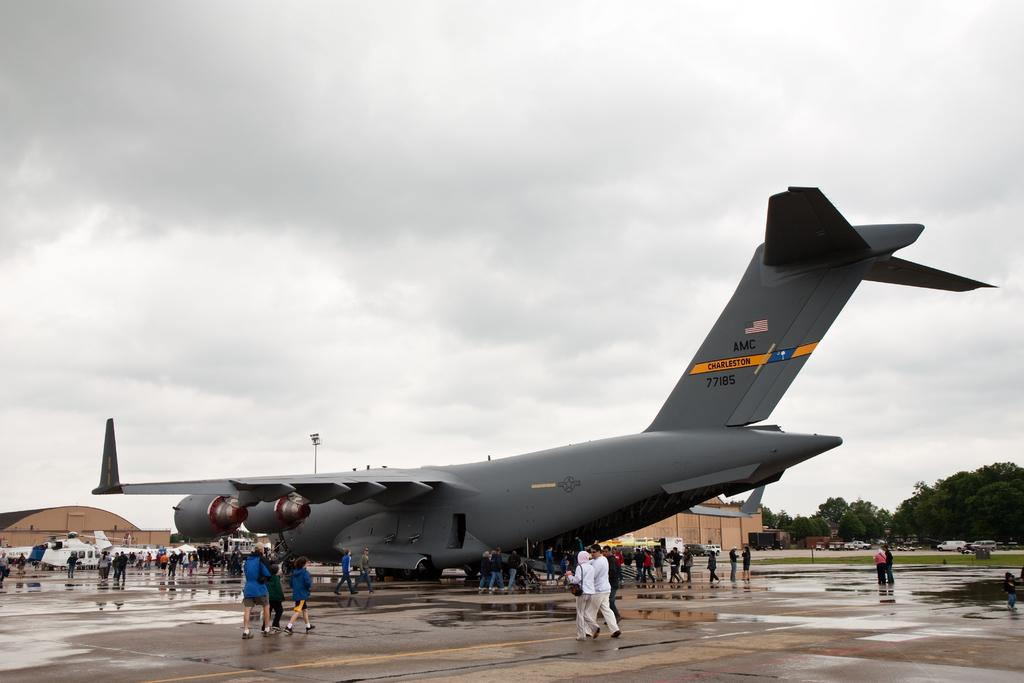What is the main subject of the image? The main subject of the image is planes. Can you describe the people in the image? There is a group of people in the image. What can be seen in the background of the image? There are buildings, vehicles, trees, and clouds in the background of the image. What type of insurance policy do the planes in the image have? There is no information about insurance policies for the planes in the image. How does the comparison between the planes and the trees in the image help us understand the image better? There is no comparison made between the planes and the trees in the image, as they are separate elements in the background. 